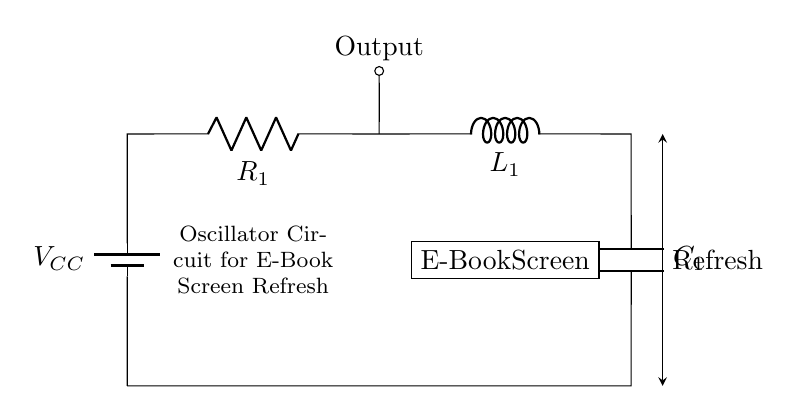What type of circuit is this? This circuit is an oscillator circuit, which is indicated by the arrangements of the resistor, inductor, and capacitor in a feedback loop that produces oscillations necessary for refreshing the e-book screen.
Answer: oscillator circuit What is the role of the inductor in this circuit? The inductor stores energy in a magnetic field when current flows through it. In an oscillator circuit, it helps to create oscillations by interacting with the capacitor and resistor, allowing for energy transfer and sustaining oscillation.
Answer: energy storage How many components are in this circuit? The circuit consists of four main components: a battery, a resistor, an inductor, and a capacitor. These components are arranged in a loop to form the oscillator necessary to refresh the e-book screen.
Answer: four What does the battery supply? The battery supplies the voltage necessary for the circuit's operation, denoted as V_CC, which provides the energy needed for current to flow through the circuit components.
Answer: voltage What is the significance of the output node? The output node represents where the oscillation signal is taken from the circuit, which is used to drive the e-book screen refresh mechanism. This is crucial for controlling the display's refresh state.
Answer: drive signal How do the components interact in this oscillator circuit? The resistor, inductor, and capacitor interact to form an RLC circuit that generates oscillations. The resistor provides damping, the inductor stores energy, and the capacitor allows the build-up and release of energy, all of which work together to maintain oscillations for screen refresh.
Answer: RLC interaction What is the function of the capacitor in this oscillator circuit? The capacitor stores electrical energy and releases it to the circuit, helping to create the oscillation needed for refreshing the e-book screen. Its charging and discharging cycles are vital for sustaining the oscillation.
Answer: energy release 